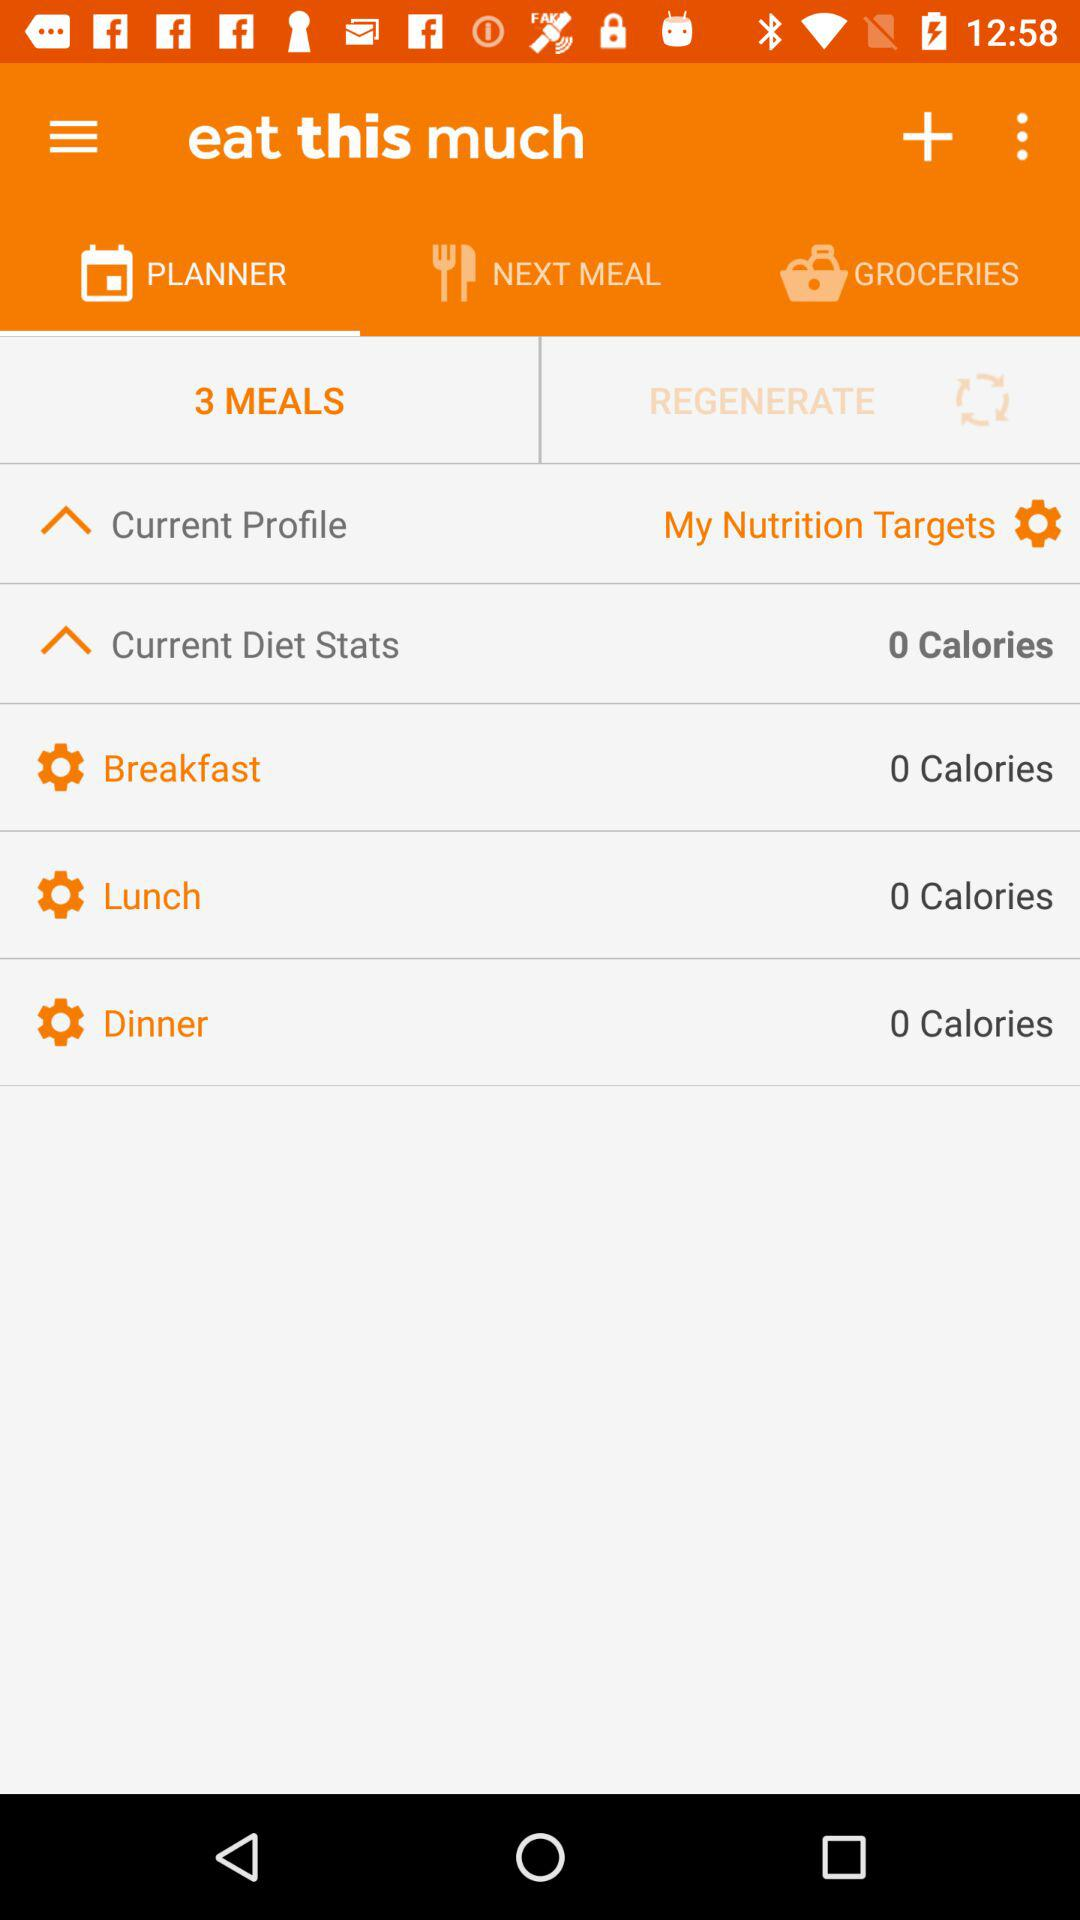How many meals are there in my planner?
Answer the question using a single word or phrase. 3 